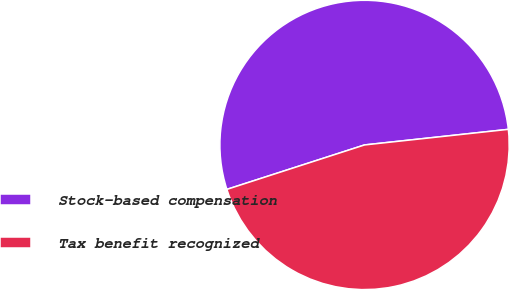Convert chart. <chart><loc_0><loc_0><loc_500><loc_500><pie_chart><fcel>Stock-based compensation<fcel>Tax benefit recognized<nl><fcel>53.25%<fcel>46.75%<nl></chart> 